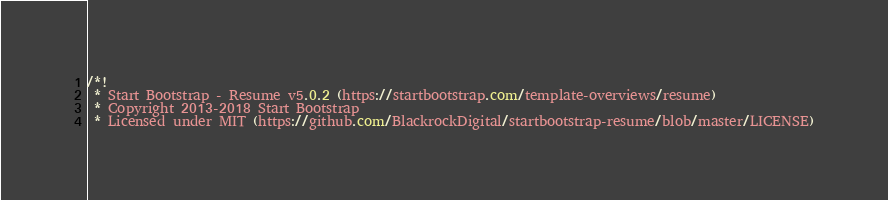<code> <loc_0><loc_0><loc_500><loc_500><_CSS_>/*!
 * Start Bootstrap - Resume v5.0.2 (https://startbootstrap.com/template-overviews/resume)
 * Copyright 2013-2018 Start Bootstrap
 * Licensed under MIT (https://github.com/BlackrockDigital/startbootstrap-resume/blob/master/LICENSE)</code> 